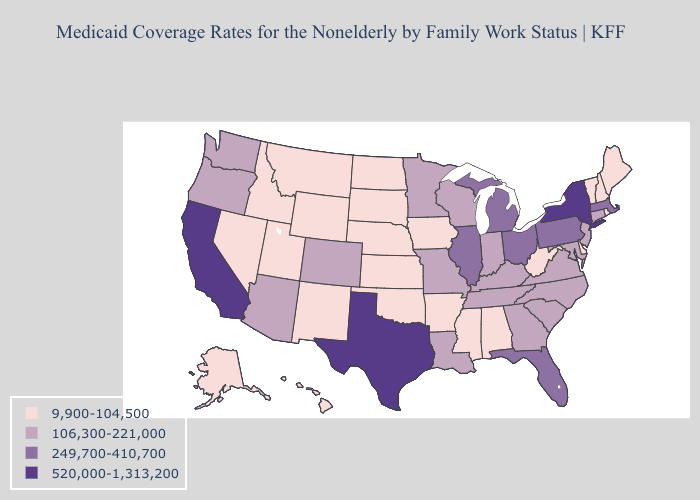Does Texas have the highest value in the USA?
Answer briefly. Yes. What is the lowest value in states that border Georgia?
Give a very brief answer. 9,900-104,500. Name the states that have a value in the range 520,000-1,313,200?
Short answer required. California, New York, Texas. Which states have the lowest value in the USA?
Quick response, please. Alabama, Alaska, Arkansas, Delaware, Hawaii, Idaho, Iowa, Kansas, Maine, Mississippi, Montana, Nebraska, Nevada, New Hampshire, New Mexico, North Dakota, Oklahoma, Rhode Island, South Dakota, Utah, Vermont, West Virginia, Wyoming. What is the highest value in the USA?
Write a very short answer. 520,000-1,313,200. Among the states that border Kansas , which have the lowest value?
Keep it brief. Nebraska, Oklahoma. Name the states that have a value in the range 249,700-410,700?
Be succinct. Florida, Illinois, Massachusetts, Michigan, Ohio, Pennsylvania. What is the highest value in states that border Wisconsin?
Answer briefly. 249,700-410,700. Name the states that have a value in the range 520,000-1,313,200?
Keep it brief. California, New York, Texas. What is the highest value in the USA?
Quick response, please. 520,000-1,313,200. Among the states that border Mississippi , does Alabama have the lowest value?
Be succinct. Yes. What is the value of Wyoming?
Quick response, please. 9,900-104,500. What is the value of Wyoming?
Be succinct. 9,900-104,500. Does New Mexico have a lower value than Nevada?
Write a very short answer. No. Does the map have missing data?
Answer briefly. No. 